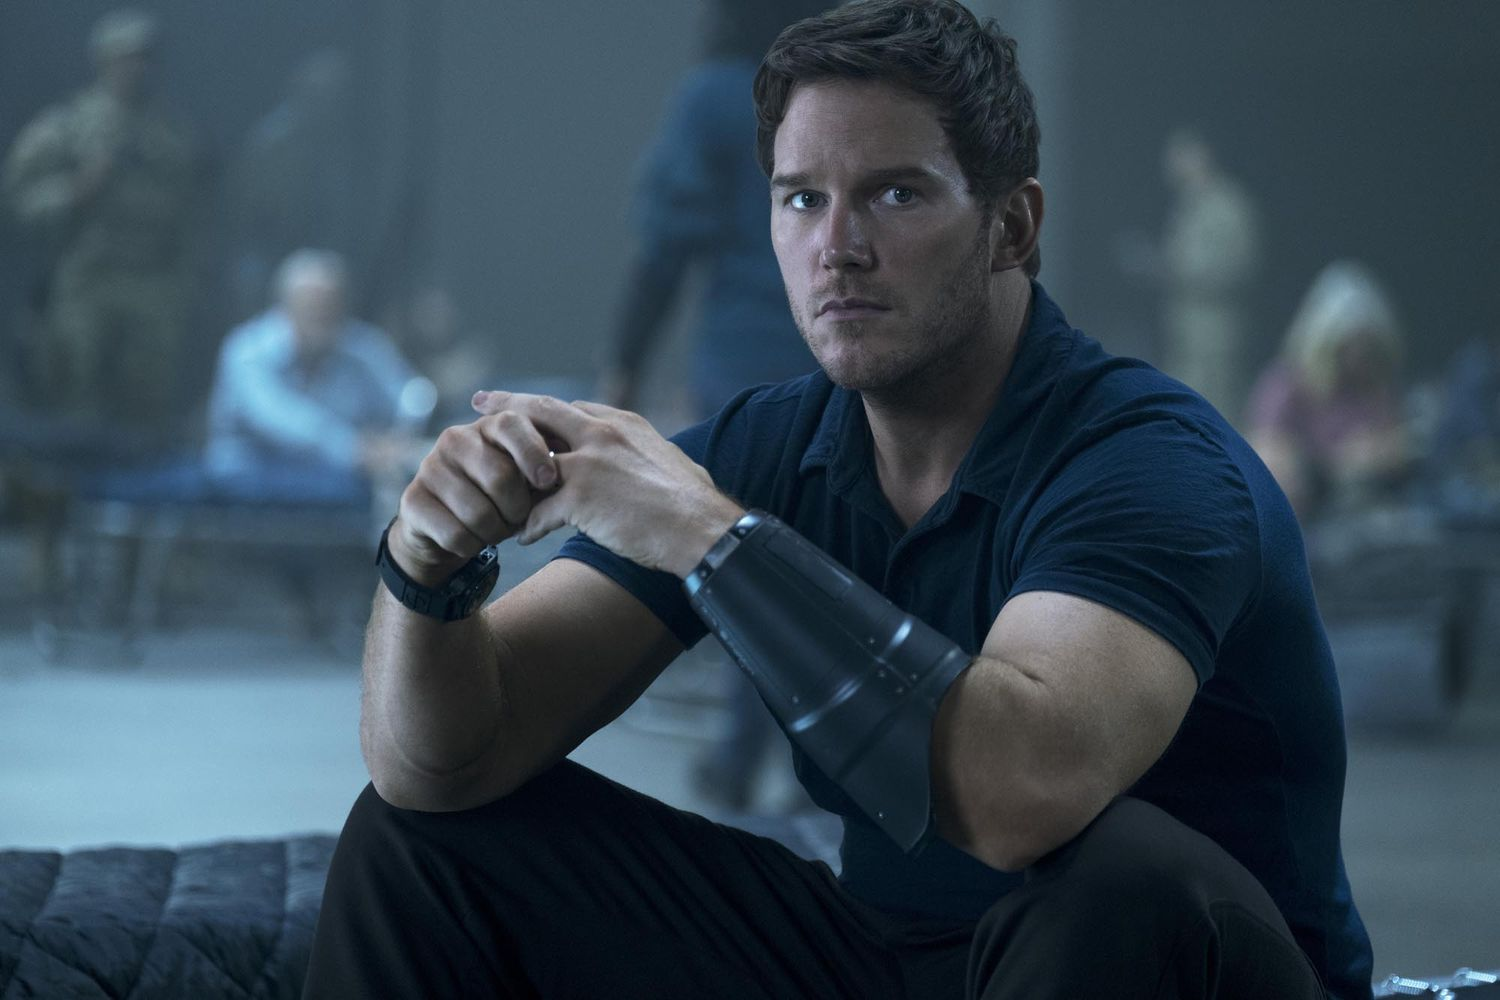If you could ask the character one question, what would it be? "What is the most important thing you're fighting for right now?" This question could elicit a revealing answer about the character's personal motivations, the stakes of the situation, and what drives him through the intense and demanding circumstances he finds himself in. 